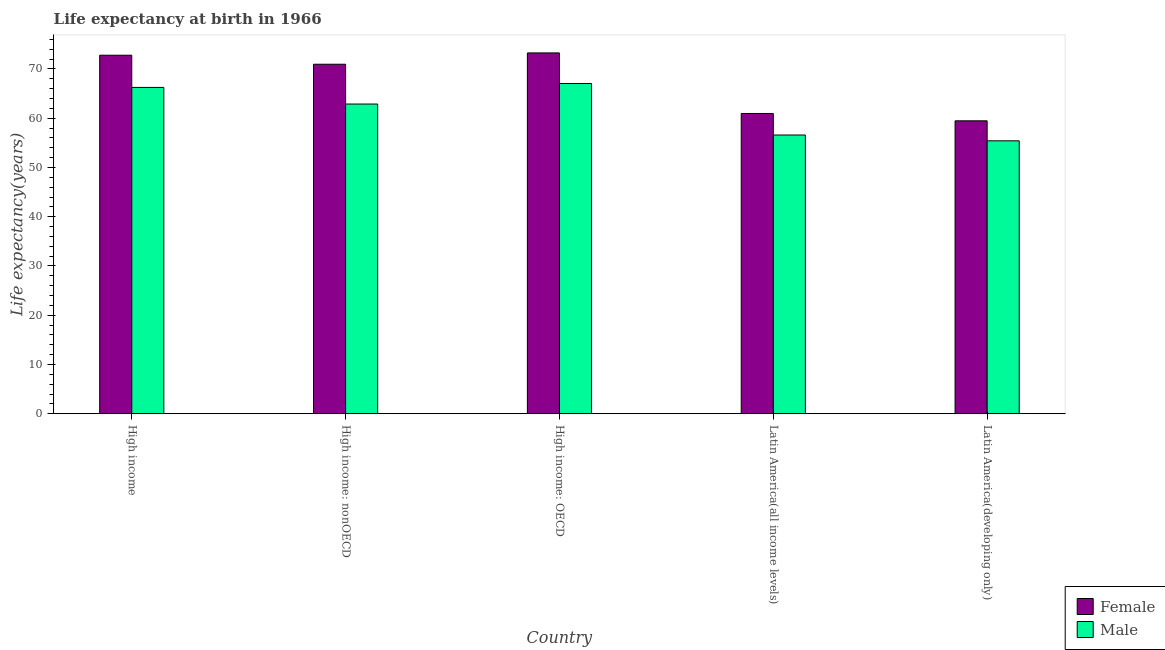How many groups of bars are there?
Ensure brevity in your answer.  5. Are the number of bars on each tick of the X-axis equal?
Provide a short and direct response. Yes. How many bars are there on the 4th tick from the right?
Provide a short and direct response. 2. What is the label of the 4th group of bars from the left?
Provide a succinct answer. Latin America(all income levels). What is the life expectancy(male) in High income?
Make the answer very short. 66.26. Across all countries, what is the maximum life expectancy(male)?
Offer a very short reply. 67.06. Across all countries, what is the minimum life expectancy(male)?
Your answer should be compact. 55.42. In which country was the life expectancy(female) maximum?
Ensure brevity in your answer.  High income: OECD. In which country was the life expectancy(male) minimum?
Offer a very short reply. Latin America(developing only). What is the total life expectancy(male) in the graph?
Your answer should be very brief. 308.22. What is the difference between the life expectancy(female) in High income: OECD and that in Latin America(developing only)?
Your response must be concise. 13.79. What is the difference between the life expectancy(male) in High income: OECD and the life expectancy(female) in Latin America(all income levels)?
Offer a terse response. 6.09. What is the average life expectancy(female) per country?
Your answer should be very brief. 67.49. What is the difference between the life expectancy(female) and life expectancy(male) in Latin America(all income levels)?
Ensure brevity in your answer.  4.37. In how many countries, is the life expectancy(female) greater than 16 years?
Ensure brevity in your answer.  5. What is the ratio of the life expectancy(female) in Latin America(all income levels) to that in Latin America(developing only)?
Provide a succinct answer. 1.03. What is the difference between the highest and the second highest life expectancy(male)?
Your answer should be very brief. 0.8. What is the difference between the highest and the lowest life expectancy(male)?
Provide a short and direct response. 11.64. In how many countries, is the life expectancy(female) greater than the average life expectancy(female) taken over all countries?
Your answer should be compact. 3. Is the sum of the life expectancy(male) in High income: OECD and Latin America(developing only) greater than the maximum life expectancy(female) across all countries?
Keep it short and to the point. Yes. What does the 1st bar from the right in High income: nonOECD represents?
Keep it short and to the point. Male. Are all the bars in the graph horizontal?
Make the answer very short. No. What is the difference between two consecutive major ticks on the Y-axis?
Offer a terse response. 10. Are the values on the major ticks of Y-axis written in scientific E-notation?
Keep it short and to the point. No. Does the graph contain grids?
Offer a terse response. No. Where does the legend appear in the graph?
Ensure brevity in your answer.  Bottom right. How many legend labels are there?
Your response must be concise. 2. How are the legend labels stacked?
Provide a short and direct response. Vertical. What is the title of the graph?
Make the answer very short. Life expectancy at birth in 1966. What is the label or title of the X-axis?
Your answer should be very brief. Country. What is the label or title of the Y-axis?
Give a very brief answer. Life expectancy(years). What is the Life expectancy(years) of Female in High income?
Your response must be concise. 72.8. What is the Life expectancy(years) of Male in High income?
Provide a short and direct response. 66.26. What is the Life expectancy(years) in Female in High income: nonOECD?
Provide a succinct answer. 70.96. What is the Life expectancy(years) in Male in High income: nonOECD?
Your answer should be very brief. 62.88. What is the Life expectancy(years) in Female in High income: OECD?
Offer a terse response. 73.27. What is the Life expectancy(years) of Male in High income: OECD?
Provide a short and direct response. 67.06. What is the Life expectancy(years) in Female in Latin America(all income levels)?
Offer a terse response. 60.97. What is the Life expectancy(years) of Male in Latin America(all income levels)?
Offer a terse response. 56.6. What is the Life expectancy(years) in Female in Latin America(developing only)?
Ensure brevity in your answer.  59.48. What is the Life expectancy(years) in Male in Latin America(developing only)?
Your answer should be very brief. 55.42. Across all countries, what is the maximum Life expectancy(years) in Female?
Give a very brief answer. 73.27. Across all countries, what is the maximum Life expectancy(years) in Male?
Your answer should be very brief. 67.06. Across all countries, what is the minimum Life expectancy(years) of Female?
Your response must be concise. 59.48. Across all countries, what is the minimum Life expectancy(years) of Male?
Your answer should be very brief. 55.42. What is the total Life expectancy(years) of Female in the graph?
Your answer should be compact. 337.47. What is the total Life expectancy(years) in Male in the graph?
Provide a succinct answer. 308.22. What is the difference between the Life expectancy(years) of Female in High income and that in High income: nonOECD?
Keep it short and to the point. 1.83. What is the difference between the Life expectancy(years) in Male in High income and that in High income: nonOECD?
Provide a succinct answer. 3.38. What is the difference between the Life expectancy(years) of Female in High income and that in High income: OECD?
Offer a very short reply. -0.47. What is the difference between the Life expectancy(years) in Male in High income and that in High income: OECD?
Offer a terse response. -0.8. What is the difference between the Life expectancy(years) of Female in High income and that in Latin America(all income levels)?
Offer a terse response. 11.83. What is the difference between the Life expectancy(years) of Male in High income and that in Latin America(all income levels)?
Keep it short and to the point. 9.67. What is the difference between the Life expectancy(years) of Female in High income and that in Latin America(developing only)?
Offer a terse response. 13.32. What is the difference between the Life expectancy(years) in Male in High income and that in Latin America(developing only)?
Your answer should be compact. 10.85. What is the difference between the Life expectancy(years) in Female in High income: nonOECD and that in High income: OECD?
Ensure brevity in your answer.  -2.3. What is the difference between the Life expectancy(years) in Male in High income: nonOECD and that in High income: OECD?
Offer a very short reply. -4.18. What is the difference between the Life expectancy(years) of Female in High income: nonOECD and that in Latin America(all income levels)?
Provide a short and direct response. 10. What is the difference between the Life expectancy(years) of Male in High income: nonOECD and that in Latin America(all income levels)?
Your response must be concise. 6.29. What is the difference between the Life expectancy(years) of Female in High income: nonOECD and that in Latin America(developing only)?
Provide a short and direct response. 11.49. What is the difference between the Life expectancy(years) of Male in High income: nonOECD and that in Latin America(developing only)?
Offer a very short reply. 7.47. What is the difference between the Life expectancy(years) in Female in High income: OECD and that in Latin America(all income levels)?
Your response must be concise. 12.3. What is the difference between the Life expectancy(years) of Male in High income: OECD and that in Latin America(all income levels)?
Ensure brevity in your answer.  10.46. What is the difference between the Life expectancy(years) in Female in High income: OECD and that in Latin America(developing only)?
Ensure brevity in your answer.  13.79. What is the difference between the Life expectancy(years) of Male in High income: OECD and that in Latin America(developing only)?
Ensure brevity in your answer.  11.64. What is the difference between the Life expectancy(years) of Female in Latin America(all income levels) and that in Latin America(developing only)?
Provide a succinct answer. 1.49. What is the difference between the Life expectancy(years) of Male in Latin America(all income levels) and that in Latin America(developing only)?
Ensure brevity in your answer.  1.18. What is the difference between the Life expectancy(years) in Female in High income and the Life expectancy(years) in Male in High income: nonOECD?
Provide a succinct answer. 9.91. What is the difference between the Life expectancy(years) of Female in High income and the Life expectancy(years) of Male in High income: OECD?
Ensure brevity in your answer.  5.74. What is the difference between the Life expectancy(years) in Female in High income and the Life expectancy(years) in Male in Latin America(all income levels)?
Your response must be concise. 16.2. What is the difference between the Life expectancy(years) in Female in High income and the Life expectancy(years) in Male in Latin America(developing only)?
Ensure brevity in your answer.  17.38. What is the difference between the Life expectancy(years) in Female in High income: nonOECD and the Life expectancy(years) in Male in High income: OECD?
Provide a succinct answer. 3.9. What is the difference between the Life expectancy(years) in Female in High income: nonOECD and the Life expectancy(years) in Male in Latin America(all income levels)?
Offer a very short reply. 14.37. What is the difference between the Life expectancy(years) in Female in High income: nonOECD and the Life expectancy(years) in Male in Latin America(developing only)?
Your response must be concise. 15.55. What is the difference between the Life expectancy(years) in Female in High income: OECD and the Life expectancy(years) in Male in Latin America(all income levels)?
Your response must be concise. 16.67. What is the difference between the Life expectancy(years) of Female in High income: OECD and the Life expectancy(years) of Male in Latin America(developing only)?
Your answer should be very brief. 17.85. What is the difference between the Life expectancy(years) of Female in Latin America(all income levels) and the Life expectancy(years) of Male in Latin America(developing only)?
Give a very brief answer. 5.55. What is the average Life expectancy(years) of Female per country?
Offer a terse response. 67.49. What is the average Life expectancy(years) in Male per country?
Your answer should be very brief. 61.64. What is the difference between the Life expectancy(years) of Female and Life expectancy(years) of Male in High income?
Offer a terse response. 6.53. What is the difference between the Life expectancy(years) of Female and Life expectancy(years) of Male in High income: nonOECD?
Ensure brevity in your answer.  8.08. What is the difference between the Life expectancy(years) in Female and Life expectancy(years) in Male in High income: OECD?
Offer a very short reply. 6.21. What is the difference between the Life expectancy(years) of Female and Life expectancy(years) of Male in Latin America(all income levels)?
Offer a terse response. 4.37. What is the difference between the Life expectancy(years) in Female and Life expectancy(years) in Male in Latin America(developing only)?
Keep it short and to the point. 4.06. What is the ratio of the Life expectancy(years) in Female in High income to that in High income: nonOECD?
Make the answer very short. 1.03. What is the ratio of the Life expectancy(years) of Male in High income to that in High income: nonOECD?
Provide a short and direct response. 1.05. What is the ratio of the Life expectancy(years) of Female in High income to that in Latin America(all income levels)?
Provide a succinct answer. 1.19. What is the ratio of the Life expectancy(years) in Male in High income to that in Latin America(all income levels)?
Your answer should be compact. 1.17. What is the ratio of the Life expectancy(years) in Female in High income to that in Latin America(developing only)?
Your answer should be compact. 1.22. What is the ratio of the Life expectancy(years) of Male in High income to that in Latin America(developing only)?
Keep it short and to the point. 1.2. What is the ratio of the Life expectancy(years) in Female in High income: nonOECD to that in High income: OECD?
Your answer should be very brief. 0.97. What is the ratio of the Life expectancy(years) of Male in High income: nonOECD to that in High income: OECD?
Provide a short and direct response. 0.94. What is the ratio of the Life expectancy(years) of Female in High income: nonOECD to that in Latin America(all income levels)?
Offer a very short reply. 1.16. What is the ratio of the Life expectancy(years) in Male in High income: nonOECD to that in Latin America(all income levels)?
Your answer should be compact. 1.11. What is the ratio of the Life expectancy(years) in Female in High income: nonOECD to that in Latin America(developing only)?
Offer a terse response. 1.19. What is the ratio of the Life expectancy(years) of Male in High income: nonOECD to that in Latin America(developing only)?
Your answer should be compact. 1.13. What is the ratio of the Life expectancy(years) of Female in High income: OECD to that in Latin America(all income levels)?
Give a very brief answer. 1.2. What is the ratio of the Life expectancy(years) of Male in High income: OECD to that in Latin America(all income levels)?
Your answer should be very brief. 1.18. What is the ratio of the Life expectancy(years) of Female in High income: OECD to that in Latin America(developing only)?
Your answer should be compact. 1.23. What is the ratio of the Life expectancy(years) of Male in High income: OECD to that in Latin America(developing only)?
Your response must be concise. 1.21. What is the ratio of the Life expectancy(years) in Female in Latin America(all income levels) to that in Latin America(developing only)?
Offer a very short reply. 1.03. What is the ratio of the Life expectancy(years) of Male in Latin America(all income levels) to that in Latin America(developing only)?
Your answer should be very brief. 1.02. What is the difference between the highest and the second highest Life expectancy(years) in Female?
Offer a terse response. 0.47. What is the difference between the highest and the second highest Life expectancy(years) in Male?
Make the answer very short. 0.8. What is the difference between the highest and the lowest Life expectancy(years) in Female?
Your answer should be very brief. 13.79. What is the difference between the highest and the lowest Life expectancy(years) of Male?
Keep it short and to the point. 11.64. 